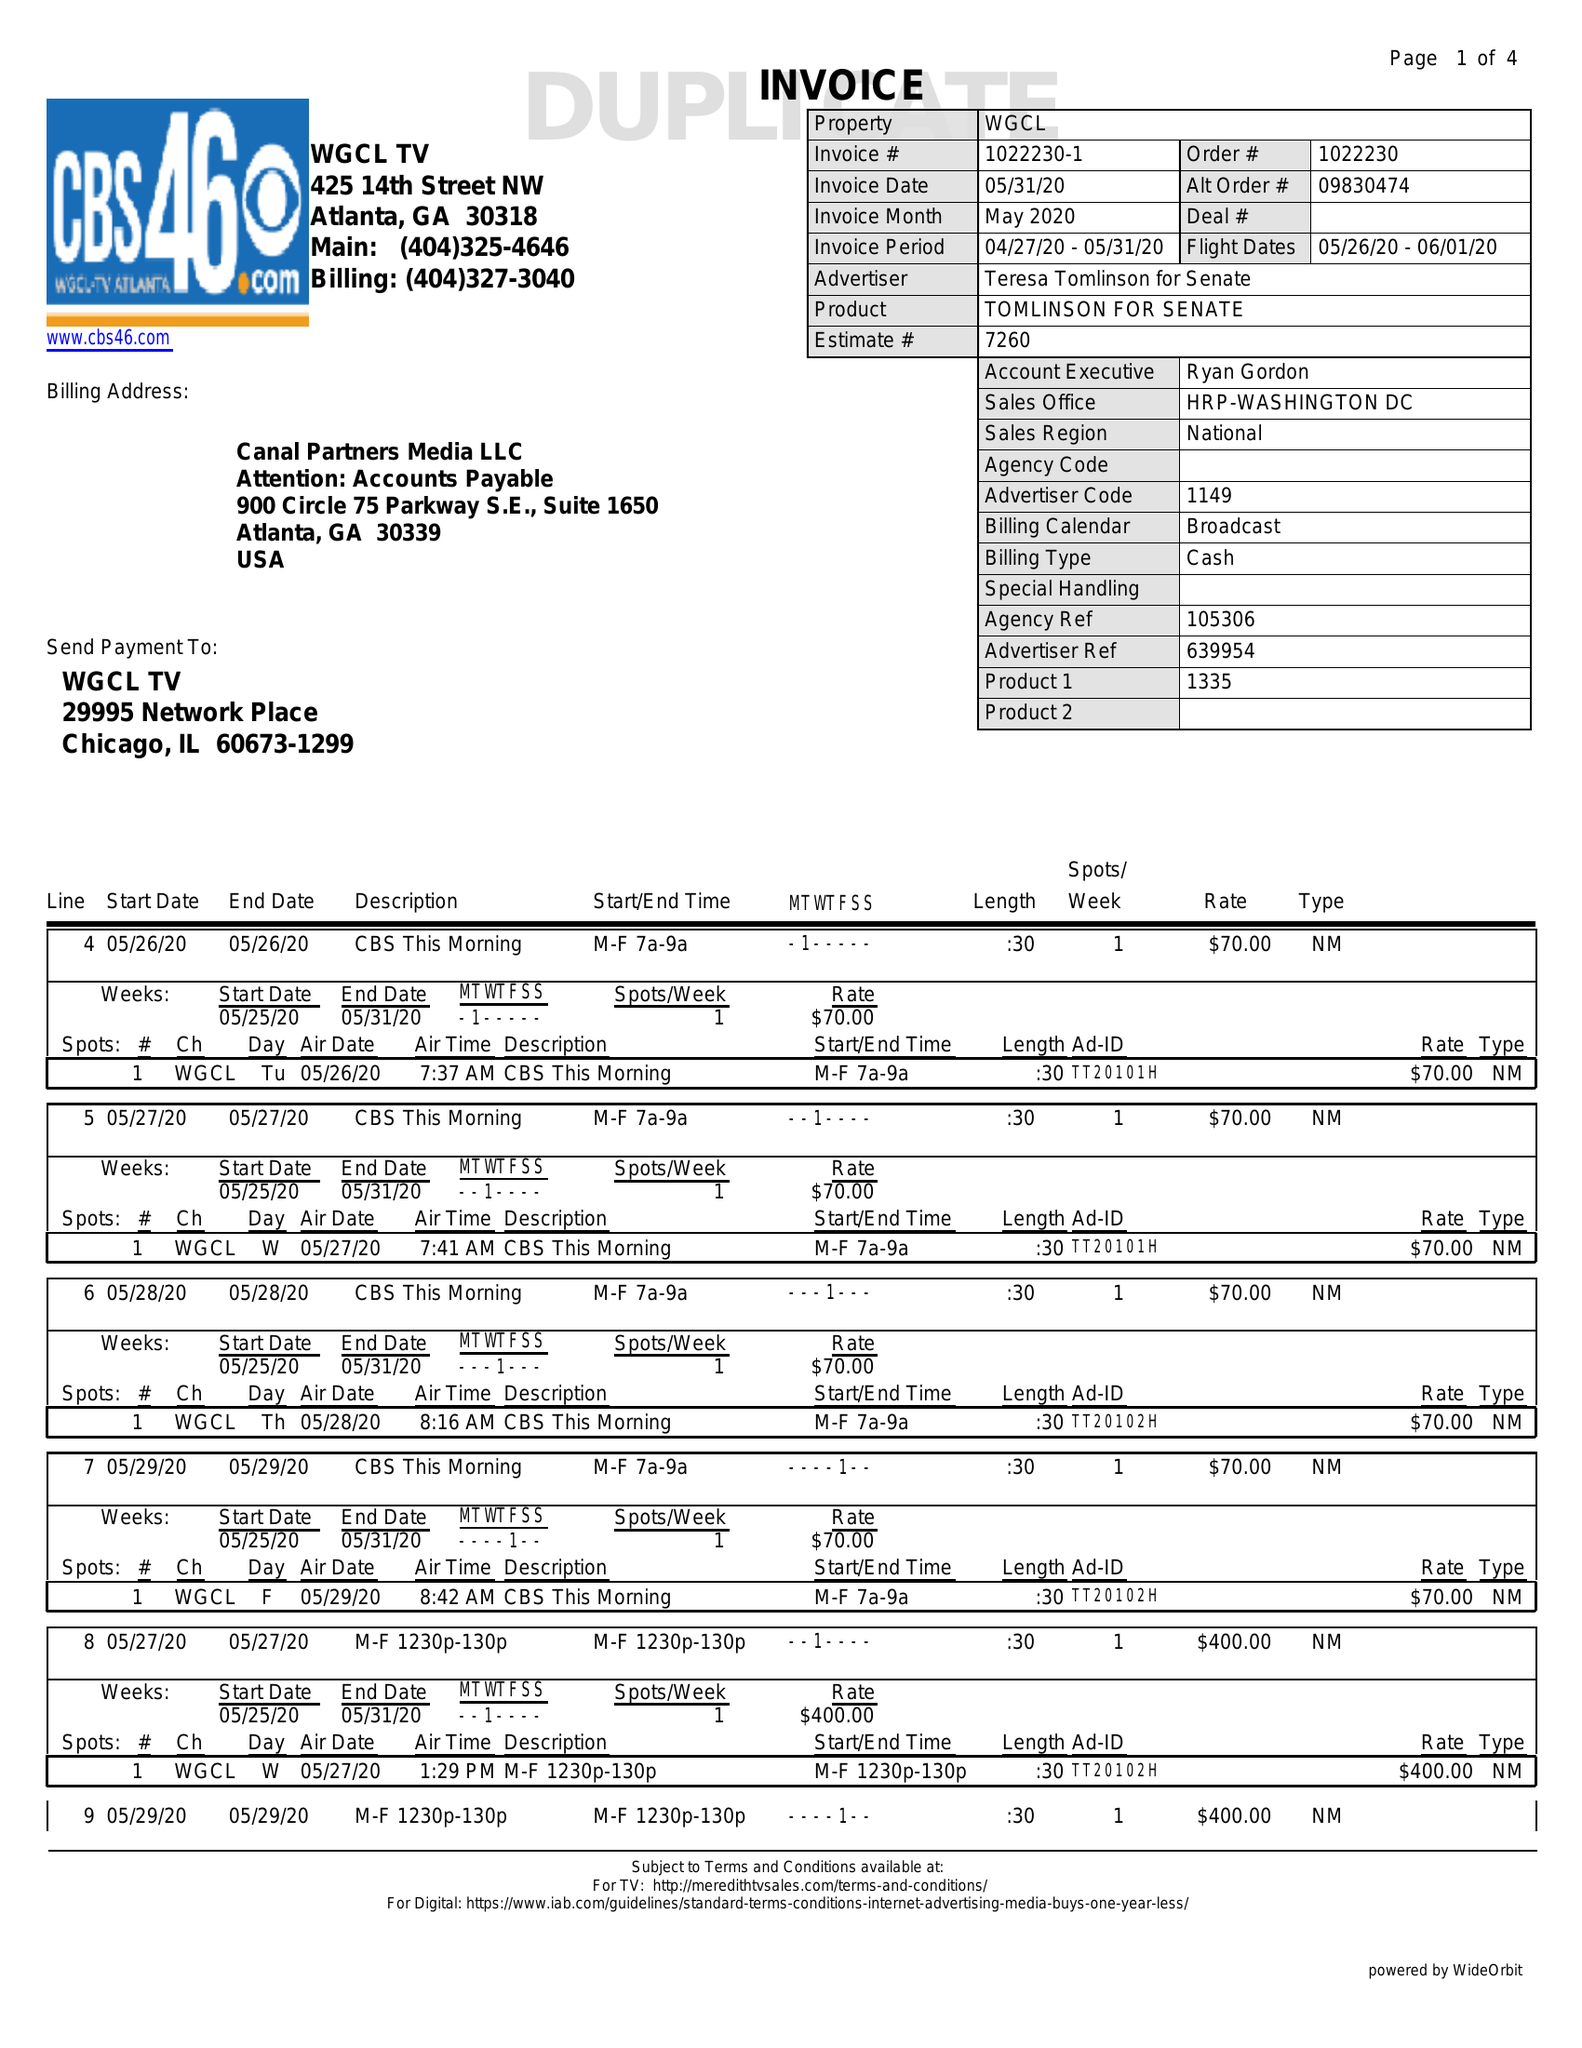What is the value for the gross_amount?
Answer the question using a single word or phrase. 5780.00 